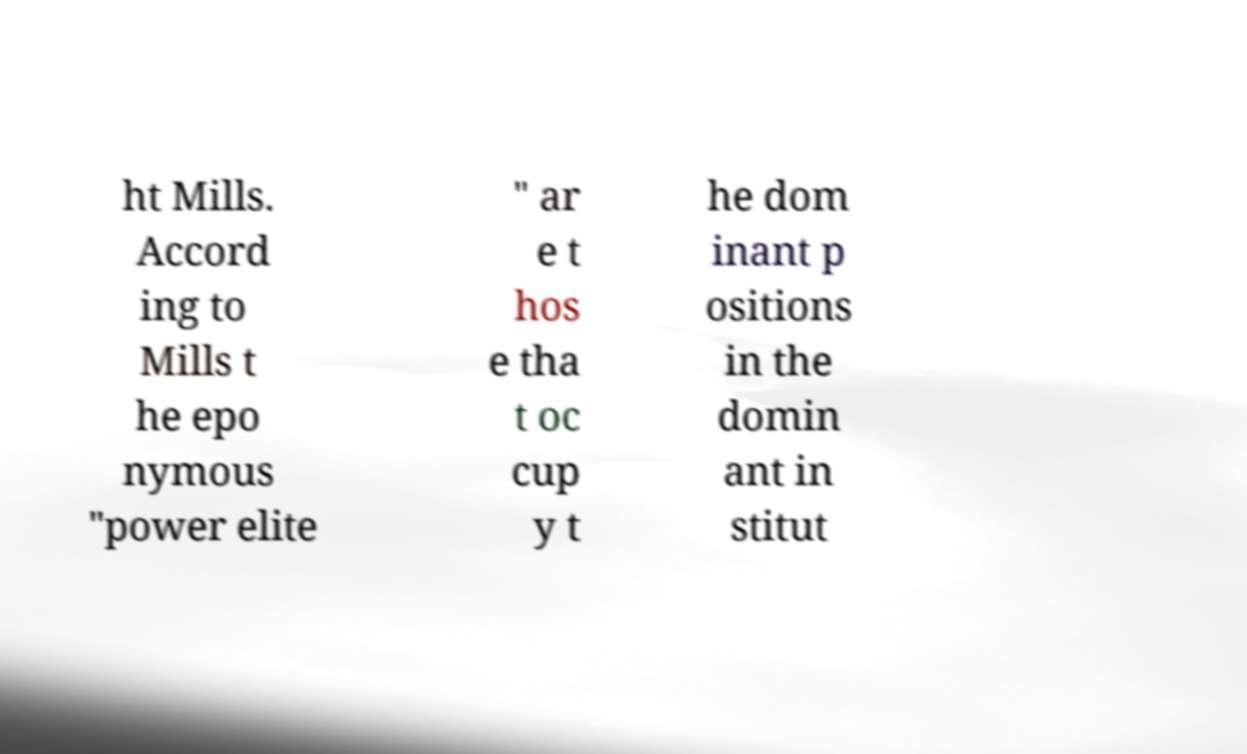For documentation purposes, I need the text within this image transcribed. Could you provide that? ht Mills. Accord ing to Mills t he epo nymous "power elite " ar e t hos e tha t oc cup y t he dom inant p ositions in the domin ant in stitut 